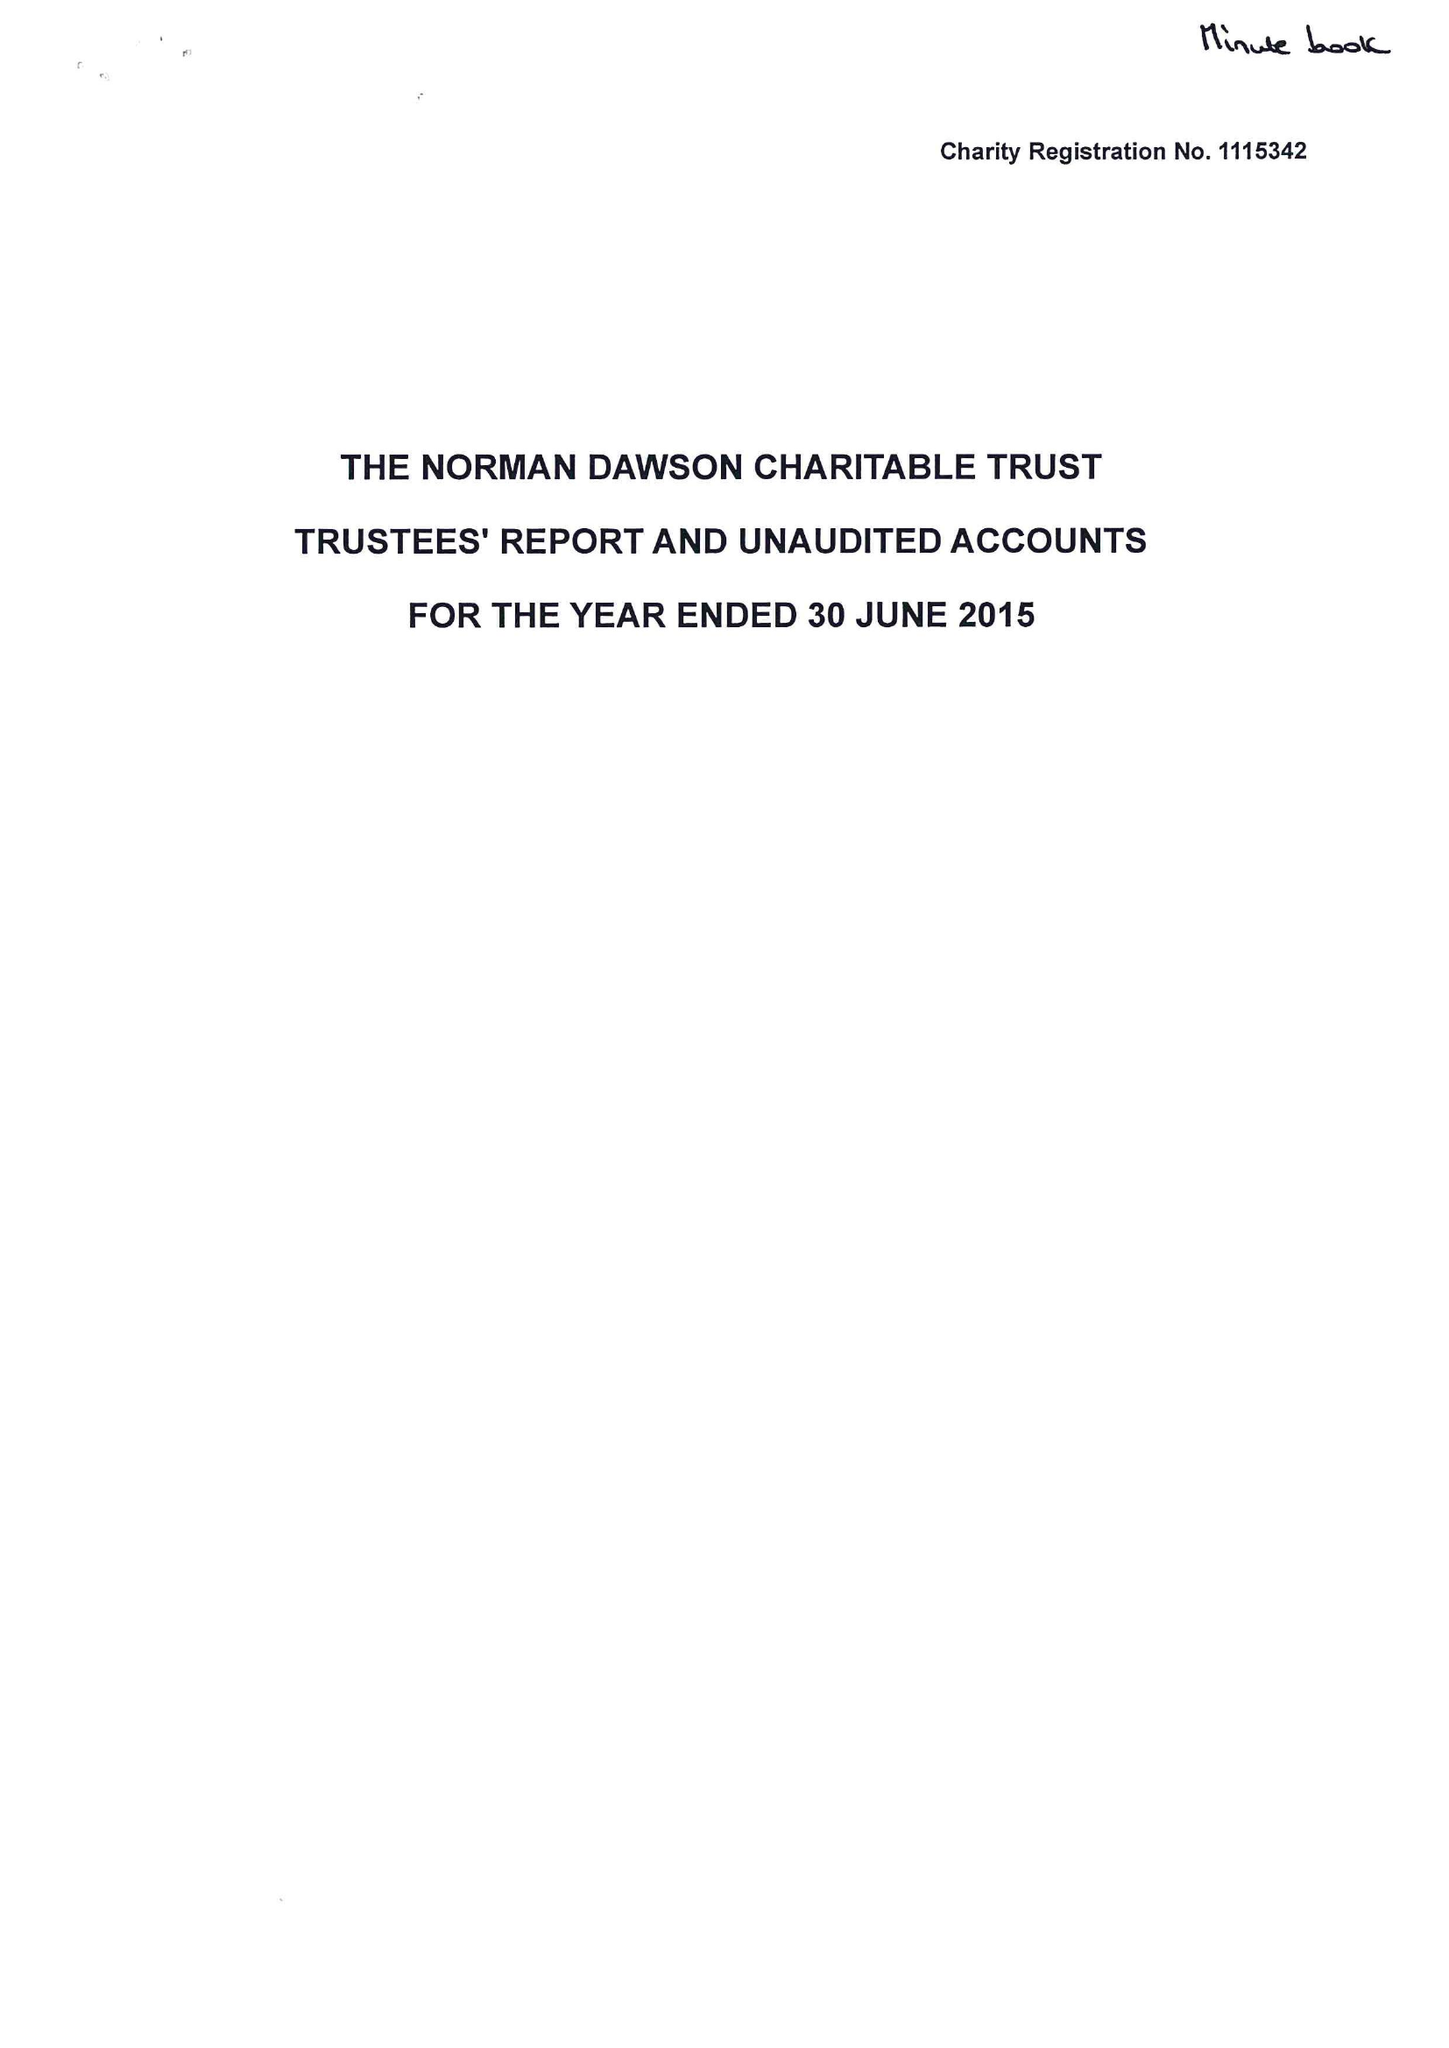What is the value for the address__post_town?
Answer the question using a single word or phrase. KIDDERMINSTER 